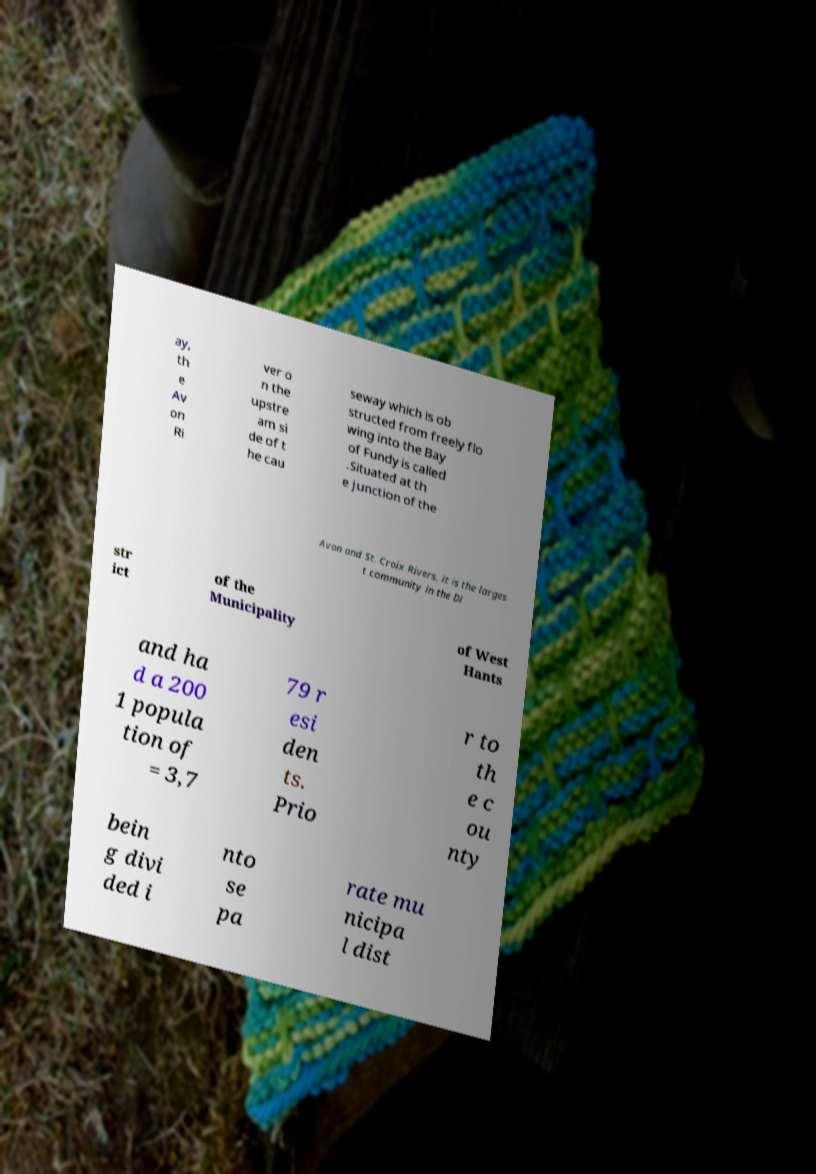For documentation purposes, I need the text within this image transcribed. Could you provide that? ay, th e Av on Ri ver o n the upstre am si de of t he cau seway which is ob structed from freely flo wing into the Bay of Fundy is called .Situated at th e junction of the Avon and St. Croix Rivers, it is the larges t community in the Di str ict of the Municipality of West Hants and ha d a 200 1 popula tion of = 3,7 79 r esi den ts. Prio r to th e c ou nty bein g divi ded i nto se pa rate mu nicipa l dist 